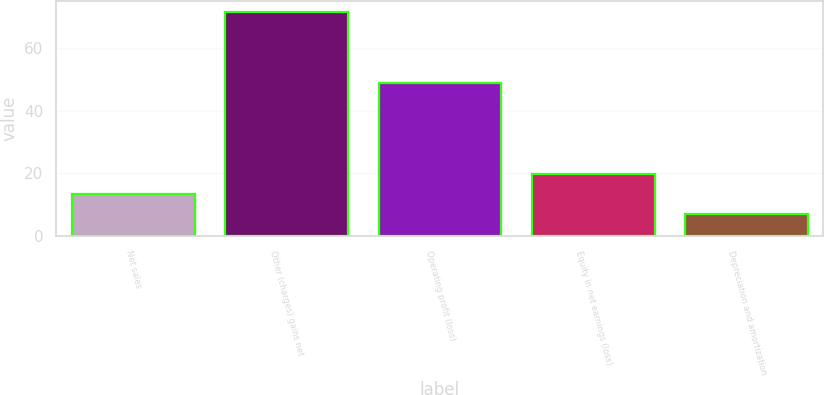Convert chart to OTSL. <chart><loc_0><loc_0><loc_500><loc_500><bar_chart><fcel>Net sales<fcel>Other (charges) gains net<fcel>Operating profit (loss)<fcel>Equity in net earnings (loss)<fcel>Depreciation and amortization<nl><fcel>13.53<fcel>71.4<fcel>48.9<fcel>19.96<fcel>7.1<nl></chart> 